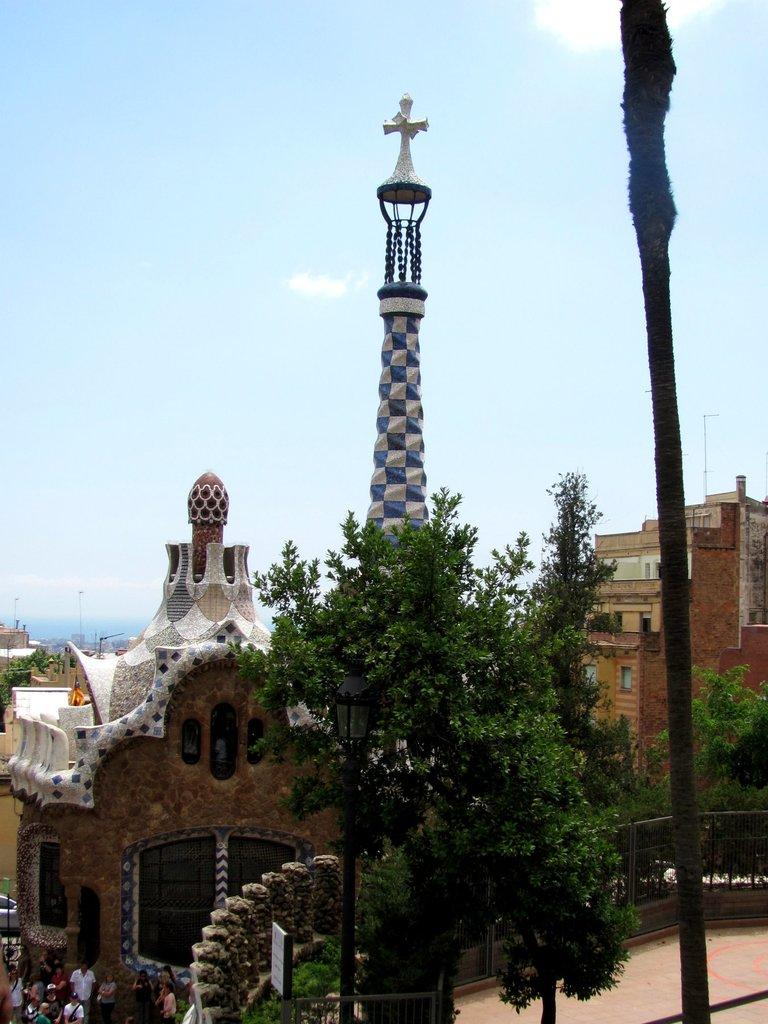Who or what can be seen in the image? There are people in the image. What type of structures are present in the image? There are buildings, a tower, and a fence in the image. What other objects can be seen in the image? There are trees, poles, and a board in the image. What is visible in the background of the image? The sky is visible in the background of the image. What type of design can be seen on the growth of the trees in the image? There is no mention of growth or design on the trees in the image; they are simply trees. 